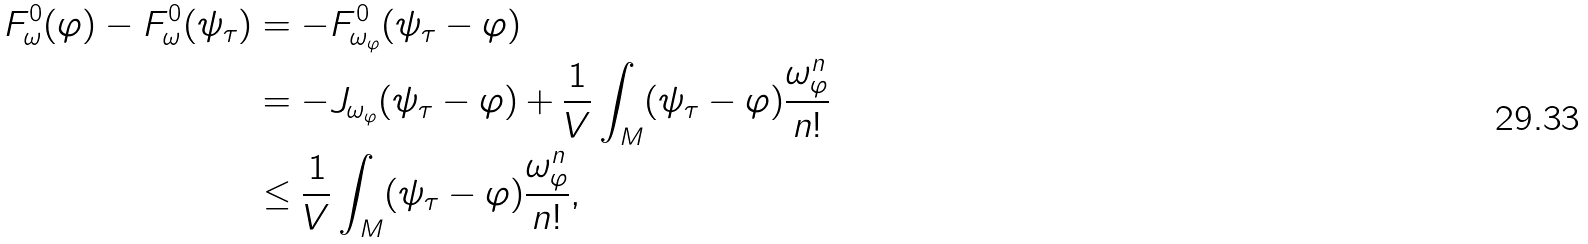Convert formula to latex. <formula><loc_0><loc_0><loc_500><loc_500>F ^ { 0 } _ { \omega } ( \varphi ) - F ^ { 0 } _ { \omega } ( \psi _ { \tau } ) & = - F ^ { 0 } _ { \omega _ { \varphi } } ( \psi _ { \tau } - \varphi ) \\ & = - J _ { \omega _ { \varphi } } ( \psi _ { \tau } - \varphi ) + \frac { 1 } { V } \int _ { M } ( \psi _ { \tau } - \varphi ) \frac { \omega _ { \varphi } ^ { n } } { n ! } \\ & \leq \frac { 1 } { V } \int _ { M } ( \psi _ { \tau } - \varphi ) \frac { \omega _ { \varphi } ^ { n } } { n ! } ,</formula> 